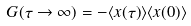Convert formula to latex. <formula><loc_0><loc_0><loc_500><loc_500>G ( \tau \rightarrow \infty ) = - \langle x ( \tau ) \rangle \langle x ( 0 ) \rangle</formula> 